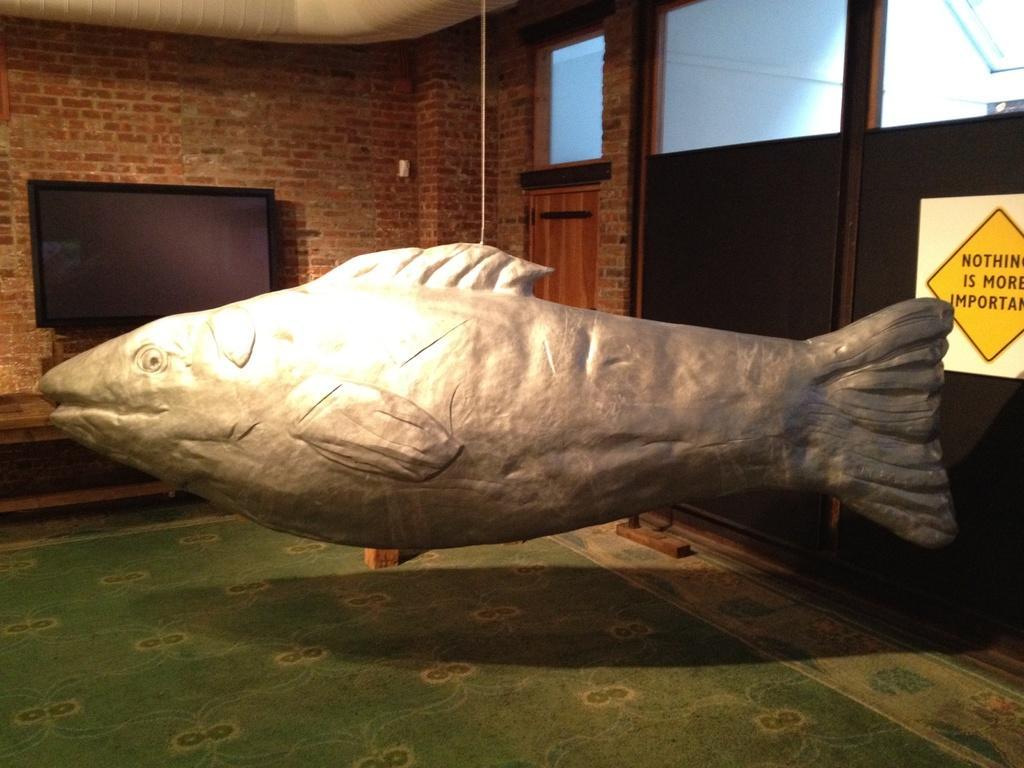In one or two sentences, can you explain what this image depicts? In this picture I can see the inside of a room and in the middle of this picture I see the depiction of a fish. On the right side of this image I see a sticker on which there is something written. In the background I see the wall on which there is a TV and on the top of this image I see the blue color things. 